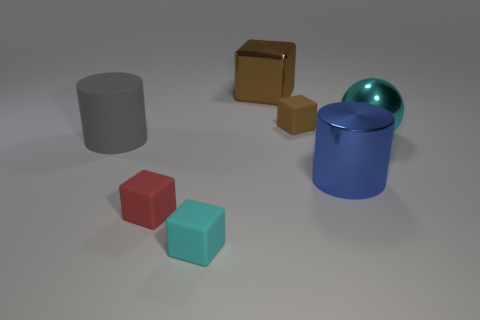Is there a green object that has the same material as the red block?
Provide a short and direct response. No. What number of big purple matte objects are there?
Your answer should be compact. 0. Is the material of the red object the same as the large cylinder that is right of the red object?
Your answer should be compact. No. There is a object that is the same color as the shiny cube; what material is it?
Provide a succinct answer. Rubber. How many matte things have the same color as the ball?
Your answer should be compact. 1. What is the size of the cyan matte object?
Offer a terse response. Small. Does the big cyan object have the same shape as the matte thing behind the ball?
Your answer should be very brief. No. There is a ball that is made of the same material as the large blue cylinder; what is its color?
Your response must be concise. Cyan. How big is the metallic thing in front of the big cyan metal ball?
Your response must be concise. Large. Is the number of cyan shiny things on the left side of the cyan matte cube less than the number of large gray rubber things?
Ensure brevity in your answer.  Yes. 